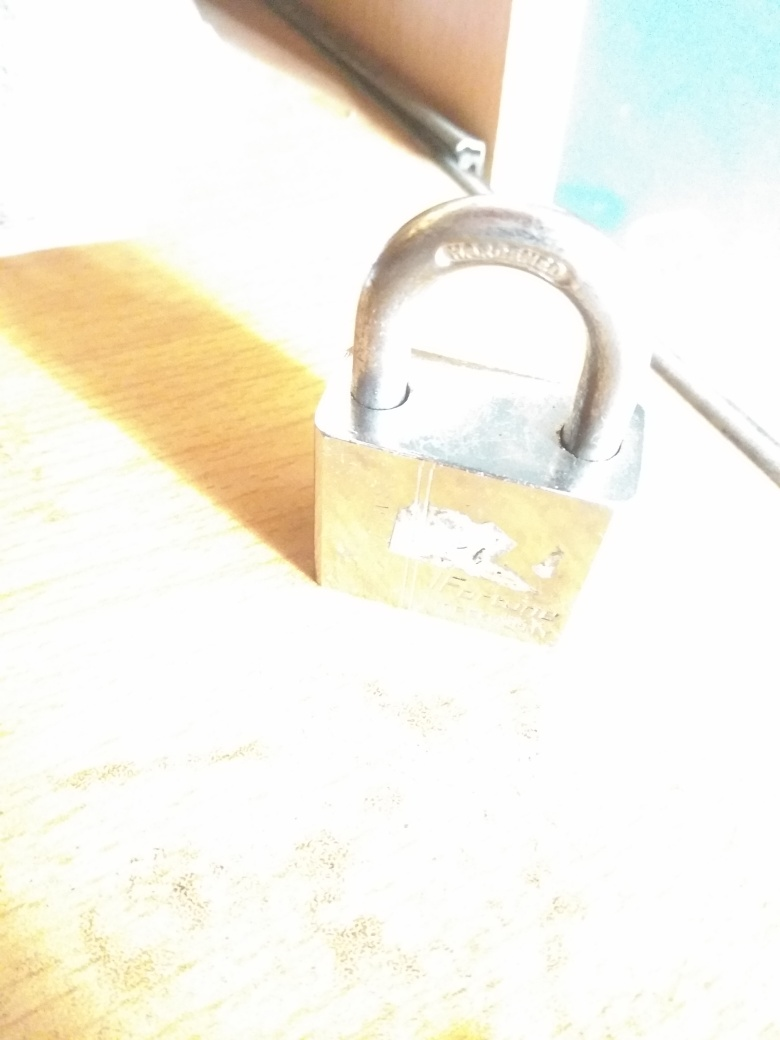What details can you observe about the subject despite the overexposure? Despite the overexposure, it is discernible that the subject is a padlock with a metallic body and shackle. The padlock's body has markings or engravings on it that might denote the manufacturer or design, but these are hard to interpret clearly because of the lighting. 